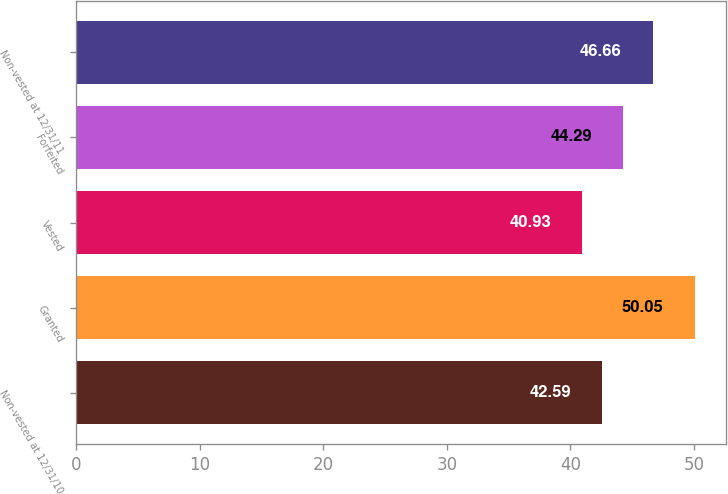<chart> <loc_0><loc_0><loc_500><loc_500><bar_chart><fcel>Non-vested at 12/31/10<fcel>Granted<fcel>Vested<fcel>Forfeited<fcel>Non-vested at 12/31/11<nl><fcel>42.59<fcel>50.05<fcel>40.93<fcel>44.29<fcel>46.66<nl></chart> 